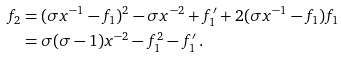<formula> <loc_0><loc_0><loc_500><loc_500>f _ { 2 } & = ( \sigma x ^ { - 1 } - f _ { 1 } ) ^ { 2 } - \sigma x ^ { - 2 } + f _ { 1 } ^ { \prime } + 2 ( \sigma x ^ { - 1 } - f _ { 1 } ) f _ { 1 } \\ & = \sigma ( \sigma - 1 ) x ^ { - 2 } - f _ { 1 } ^ { 2 } - f _ { 1 } ^ { \prime } \, .</formula> 